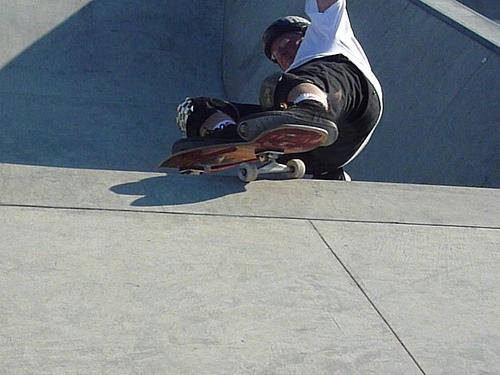What trick is he doing?
Keep it brief. Jump. Is the man wearing safety clothes?
Be succinct. Yes. Is he in danger?
Short answer required. No. 